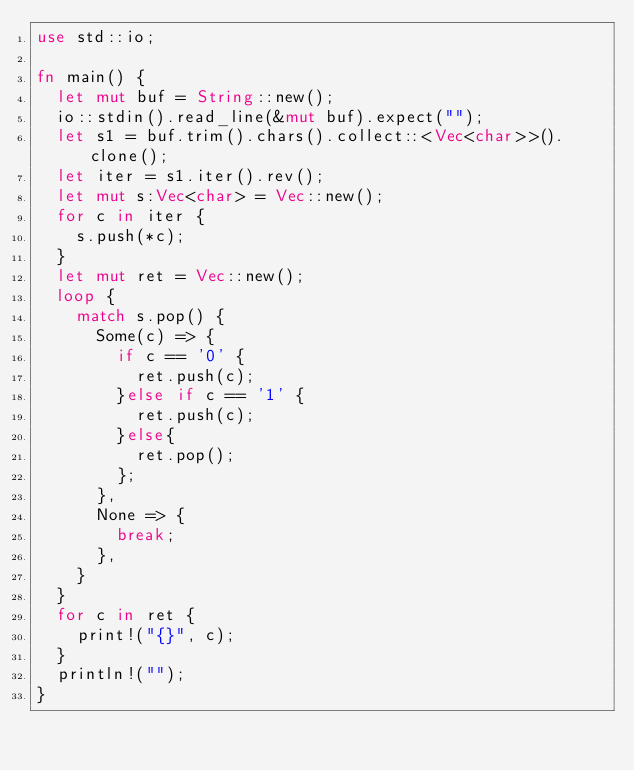<code> <loc_0><loc_0><loc_500><loc_500><_Rust_>use std::io;

fn main() {
	let mut buf = String::new();
	io::stdin().read_line(&mut buf).expect("");
	let s1 = buf.trim().chars().collect::<Vec<char>>().clone();
	let iter = s1.iter().rev();
	let mut s:Vec<char> = Vec::new();
	for c in iter {
		s.push(*c);
	}
	let mut ret = Vec::new();
	loop {
		match s.pop() {
			Some(c) => {
				if c == '0' {
					ret.push(c);
				}else if c == '1' {
					ret.push(c);
				}else{
					ret.pop();
				};
			},
			None => {
				break;
			},
		}
	}
	for c in ret {
		print!("{}", c);
	}
	println!("");
}</code> 